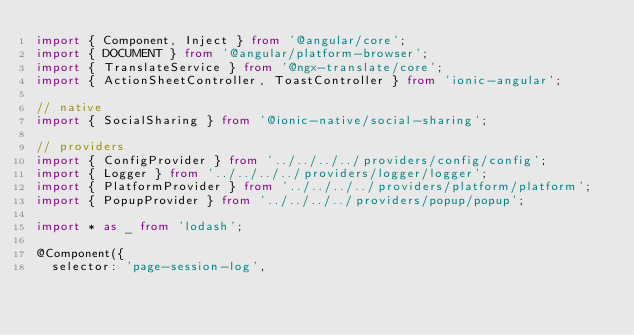Convert code to text. <code><loc_0><loc_0><loc_500><loc_500><_TypeScript_>import { Component, Inject } from '@angular/core';
import { DOCUMENT } from '@angular/platform-browser';
import { TranslateService } from '@ngx-translate/core';
import { ActionSheetController, ToastController } from 'ionic-angular';

// native
import { SocialSharing } from '@ionic-native/social-sharing';

// providers
import { ConfigProvider } from '../../../../providers/config/config';
import { Logger } from '../../../../providers/logger/logger';
import { PlatformProvider } from '../../../../providers/platform/platform';
import { PopupProvider } from '../../../../providers/popup/popup';

import * as _ from 'lodash';

@Component({
  selector: 'page-session-log',</code> 